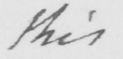Please transcribe the handwritten text in this image. this 